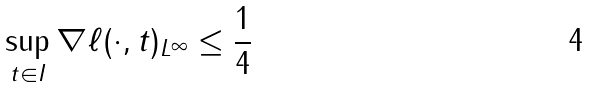<formula> <loc_0><loc_0><loc_500><loc_500>\sup _ { t \in I } \| \nabla \ell ( \cdot , t ) \| _ { L ^ { \infty } } \leq \frac { 1 } { 4 }</formula> 